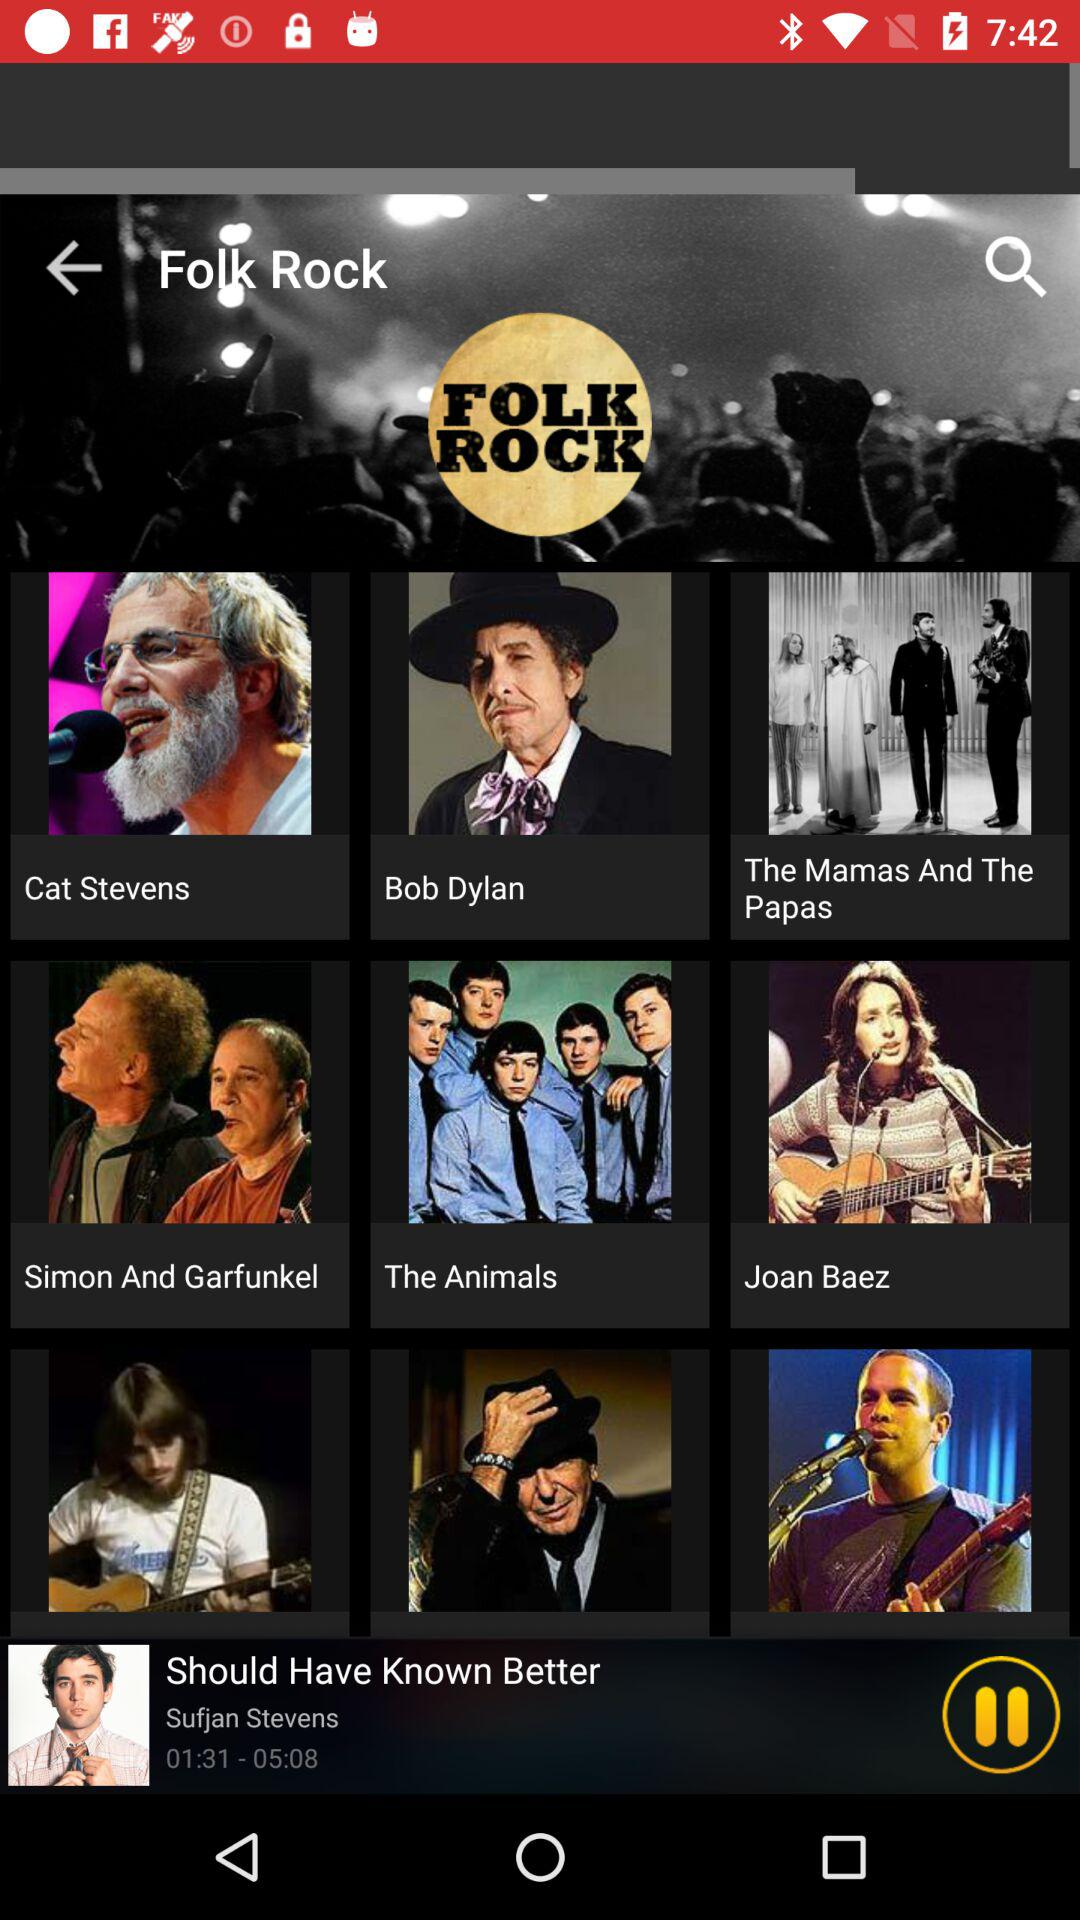Which other music genres are available?
When the provided information is insufficient, respond with <no answer>. <no answer> 